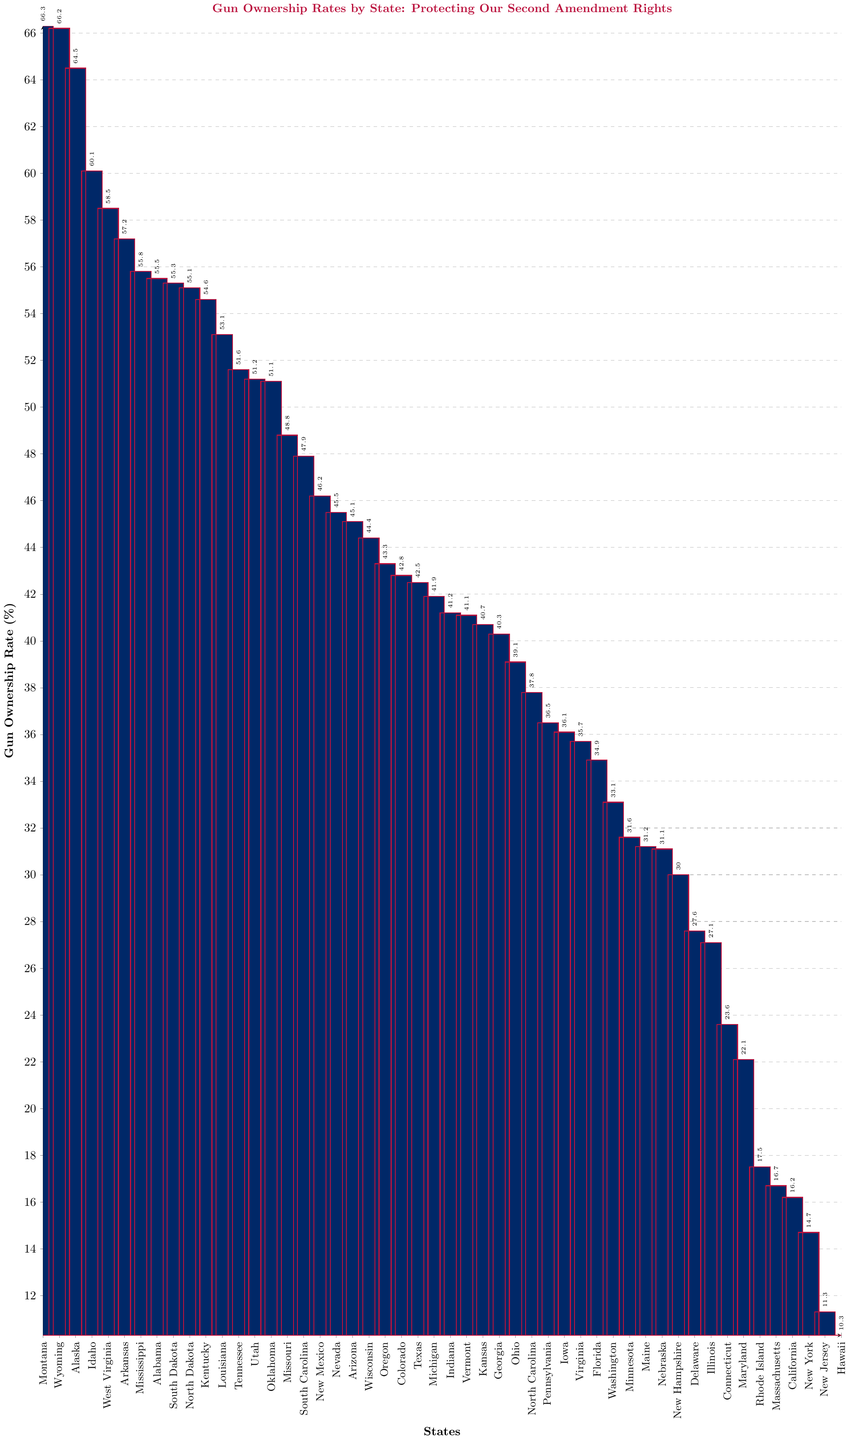which state has the highest gun ownership rate? The tallest bar represents Montana with a gun ownership rate of 66.3%.
Answer: Montana which states have gun ownership rates above 60%? All states with bars reaching above the 60% line: Montana, Wyoming, Alaska, and Idaho
Answer: Montana, Wyoming, Alaska, Idaho Compare the gun ownership rates of Montana and Wyoming. Which one is higher? Montana and Wyoming have very close rates, but Montana's bar is slightly taller, indicating a higher rate of 66.3% compared to Wyoming's 66.2%.
Answer: Montana what is the difference in gun ownership rates between the highest (Montana) and lowest (Hawaii)? Subtract Hawaii’s rate (10.3%) from Montana’s rate (66.3%) and the difference is 66.3 - 10.3 = 56%.
Answer: 56% Which state has a gun ownership rate closest to 50%? Identify the bar that is closest to the 50% mark; Tennessee's bar represents 51.6%, which is nearest to 50%.
Answer: Tennessee Which state has a higher gun ownership rate, Texas or California? Compare the bars for Texas (42.5%) and California (16.2%). Texas has a higher rate.
Answer: Texas what is the average gun ownership rate of the top five states? Sum the rates of the top five states (66.3 + 66.2 + 64.5 + 60.1 + 58.5) and divide by 5. (315.6 / 5 = 63.12)
Answer: 63.12% What is the difference in gun ownership rates between Alabama and Illinois? Subtract Illinois’ rate (27.1%) from Alabama’s rate (55.5%). The difference is 55.5 - 27.1 = 28.4%.
Answer: 28.4% how many states have gun ownership rates below 20%? Identify states with ownership rates under the 20% line: Rhode Island (17.5%), Massachusetts (16.7%), California (16.2%), New York (14.7%), New Jersey (11.3%), and Hawaii (10.3%). There are 6 such states.
Answer: 6 